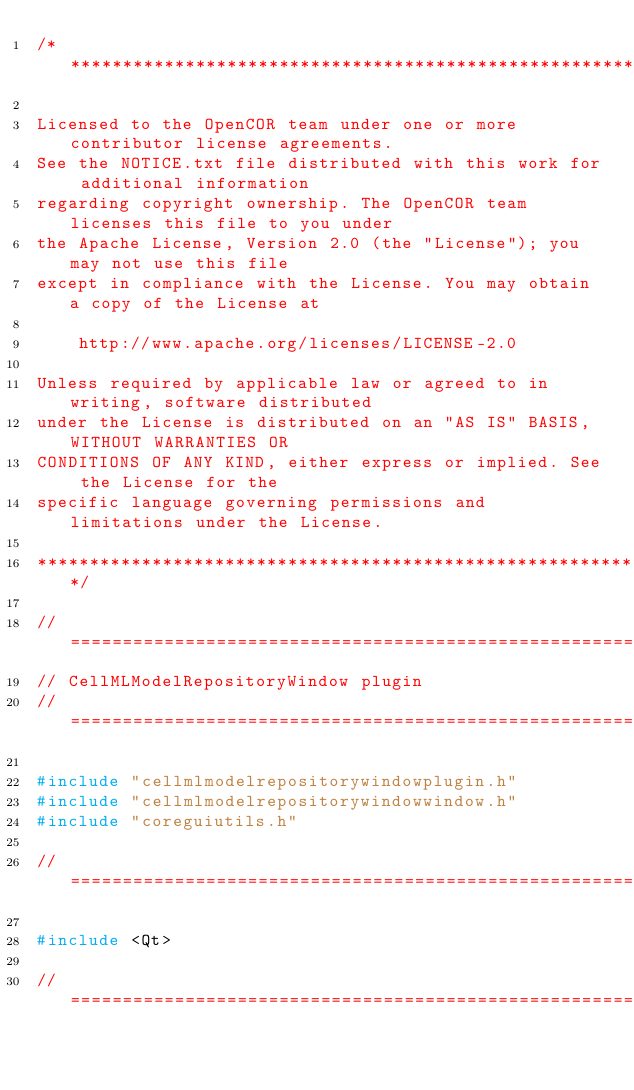Convert code to text. <code><loc_0><loc_0><loc_500><loc_500><_C++_>/*******************************************************************************

Licensed to the OpenCOR team under one or more contributor license agreements.
See the NOTICE.txt file distributed with this work for additional information
regarding copyright ownership. The OpenCOR team licenses this file to you under
the Apache License, Version 2.0 (the "License"); you may not use this file
except in compliance with the License. You may obtain a copy of the License at

    http://www.apache.org/licenses/LICENSE-2.0

Unless required by applicable law or agreed to in writing, software distributed
under the License is distributed on an "AS IS" BASIS, WITHOUT WARRANTIES OR
CONDITIONS OF ANY KIND, either express or implied. See the License for the
specific language governing permissions and limitations under the License.

*******************************************************************************/

//==============================================================================
// CellMLModelRepositoryWindow plugin
//==============================================================================

#include "cellmlmodelrepositorywindowplugin.h"
#include "cellmlmodelrepositorywindowwindow.h"
#include "coreguiutils.h"

//==============================================================================

#include <Qt>

//==============================================================================
</code> 